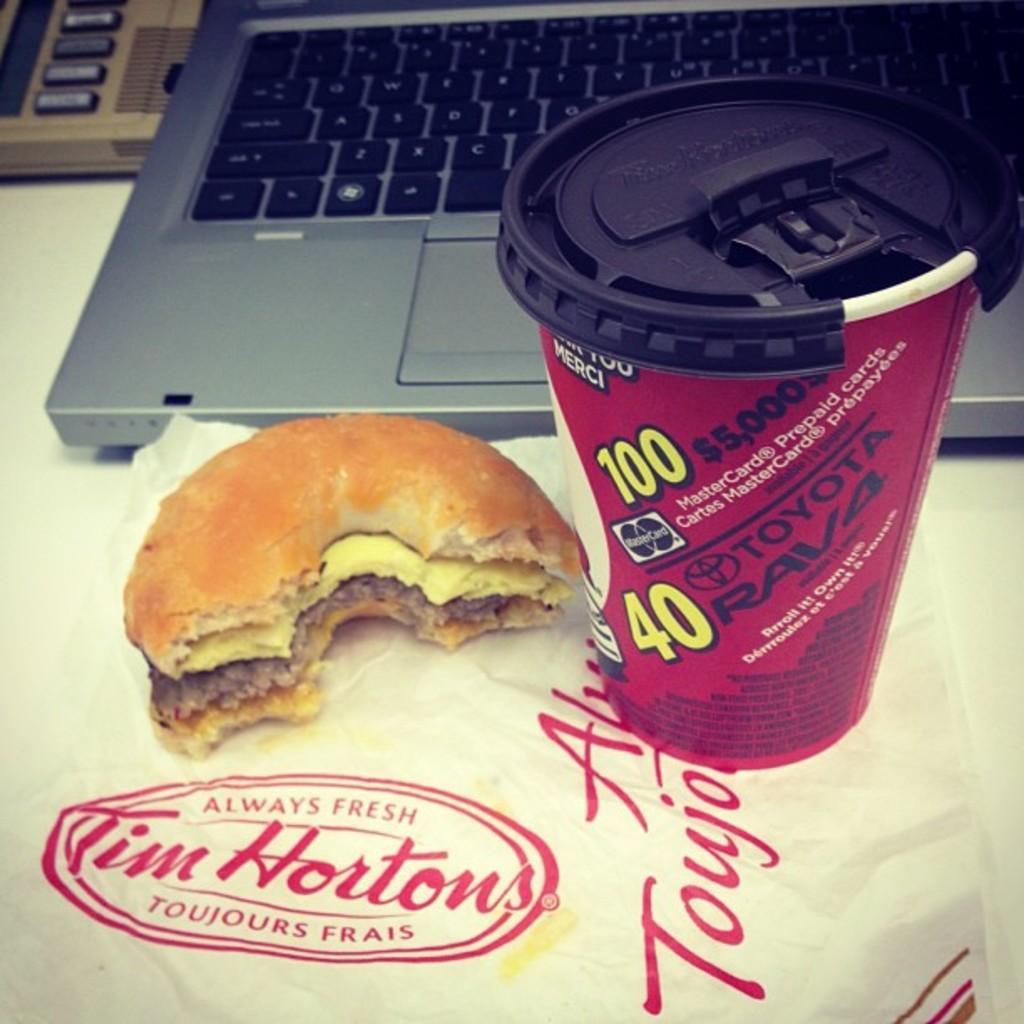Can you describe this image briefly? In this image, we can see a laptop and some food item. We can also see a glass and some posters with text. We can also see some object in the top left corner. 